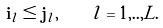Convert formula to latex. <formula><loc_0><loc_0><loc_500><loc_500>\mathbf i _ { l } \leq \mathbf j _ { l } , \quad l = 1 , . . , L .</formula> 